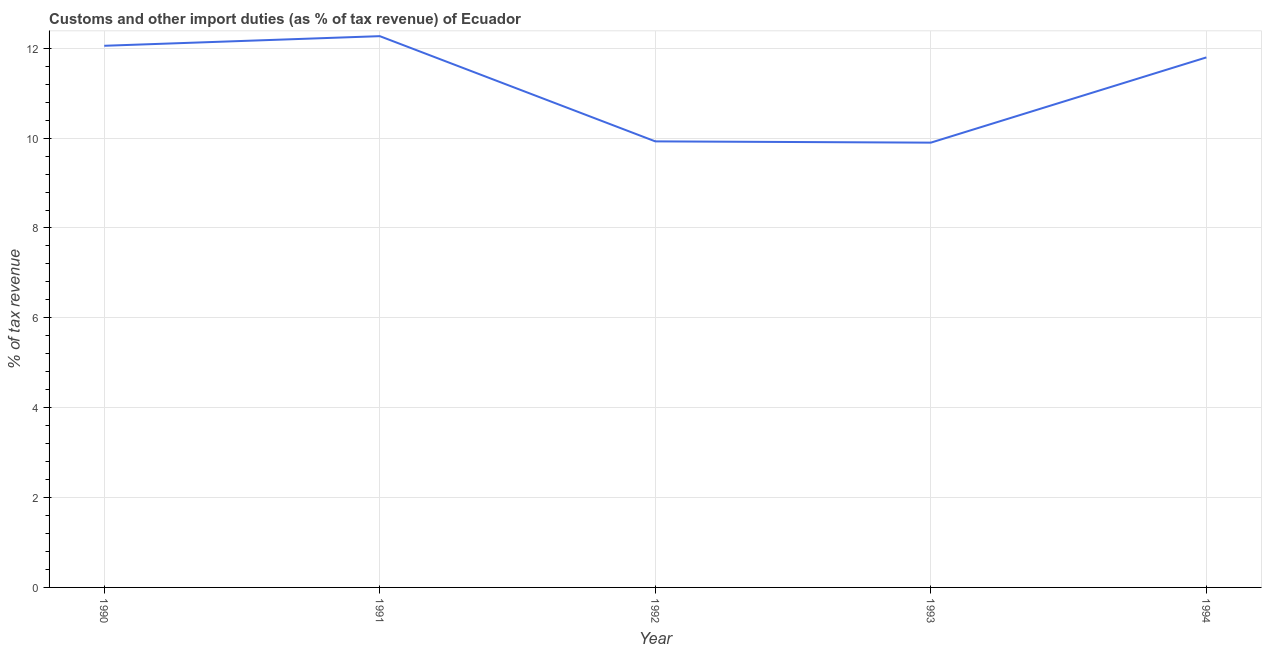What is the customs and other import duties in 1991?
Offer a terse response. 12.27. Across all years, what is the maximum customs and other import duties?
Your answer should be very brief. 12.27. Across all years, what is the minimum customs and other import duties?
Your response must be concise. 9.9. In which year was the customs and other import duties maximum?
Offer a very short reply. 1991. In which year was the customs and other import duties minimum?
Make the answer very short. 1993. What is the sum of the customs and other import duties?
Your answer should be compact. 55.95. What is the difference between the customs and other import duties in 1991 and 1992?
Keep it short and to the point. 2.34. What is the average customs and other import duties per year?
Your answer should be compact. 11.19. What is the median customs and other import duties?
Provide a short and direct response. 11.8. In how many years, is the customs and other import duties greater than 4.8 %?
Give a very brief answer. 5. Do a majority of the years between 1990 and 1992 (inclusive) have customs and other import duties greater than 9.6 %?
Make the answer very short. Yes. What is the ratio of the customs and other import duties in 1990 to that in 1993?
Offer a terse response. 1.22. Is the customs and other import duties in 1990 less than that in 1993?
Offer a terse response. No. Is the difference between the customs and other import duties in 1992 and 1994 greater than the difference between any two years?
Make the answer very short. No. What is the difference between the highest and the second highest customs and other import duties?
Provide a succinct answer. 0.21. What is the difference between the highest and the lowest customs and other import duties?
Your answer should be very brief. 2.37. In how many years, is the customs and other import duties greater than the average customs and other import duties taken over all years?
Your answer should be compact. 3. Does the customs and other import duties monotonically increase over the years?
Make the answer very short. No. How many years are there in the graph?
Offer a terse response. 5. Are the values on the major ticks of Y-axis written in scientific E-notation?
Give a very brief answer. No. Does the graph contain any zero values?
Your response must be concise. No. Does the graph contain grids?
Make the answer very short. Yes. What is the title of the graph?
Your answer should be compact. Customs and other import duties (as % of tax revenue) of Ecuador. What is the label or title of the X-axis?
Your answer should be compact. Year. What is the label or title of the Y-axis?
Keep it short and to the point. % of tax revenue. What is the % of tax revenue of 1990?
Your response must be concise. 12.05. What is the % of tax revenue in 1991?
Your answer should be compact. 12.27. What is the % of tax revenue in 1992?
Provide a short and direct response. 9.93. What is the % of tax revenue of 1993?
Provide a succinct answer. 9.9. What is the % of tax revenue of 1994?
Provide a short and direct response. 11.8. What is the difference between the % of tax revenue in 1990 and 1991?
Offer a very short reply. -0.21. What is the difference between the % of tax revenue in 1990 and 1992?
Your response must be concise. 2.13. What is the difference between the % of tax revenue in 1990 and 1993?
Offer a terse response. 2.16. What is the difference between the % of tax revenue in 1990 and 1994?
Your answer should be very brief. 0.26. What is the difference between the % of tax revenue in 1991 and 1992?
Offer a terse response. 2.34. What is the difference between the % of tax revenue in 1991 and 1993?
Your answer should be compact. 2.37. What is the difference between the % of tax revenue in 1991 and 1994?
Your answer should be compact. 0.47. What is the difference between the % of tax revenue in 1992 and 1993?
Offer a terse response. 0.03. What is the difference between the % of tax revenue in 1992 and 1994?
Provide a short and direct response. -1.87. What is the difference between the % of tax revenue in 1993 and 1994?
Offer a terse response. -1.9. What is the ratio of the % of tax revenue in 1990 to that in 1991?
Provide a short and direct response. 0.98. What is the ratio of the % of tax revenue in 1990 to that in 1992?
Offer a terse response. 1.21. What is the ratio of the % of tax revenue in 1990 to that in 1993?
Your response must be concise. 1.22. What is the ratio of the % of tax revenue in 1990 to that in 1994?
Your answer should be very brief. 1.02. What is the ratio of the % of tax revenue in 1991 to that in 1992?
Keep it short and to the point. 1.24. What is the ratio of the % of tax revenue in 1991 to that in 1993?
Provide a short and direct response. 1.24. What is the ratio of the % of tax revenue in 1991 to that in 1994?
Your answer should be very brief. 1.04. What is the ratio of the % of tax revenue in 1992 to that in 1993?
Offer a terse response. 1. What is the ratio of the % of tax revenue in 1992 to that in 1994?
Your response must be concise. 0.84. What is the ratio of the % of tax revenue in 1993 to that in 1994?
Make the answer very short. 0.84. 